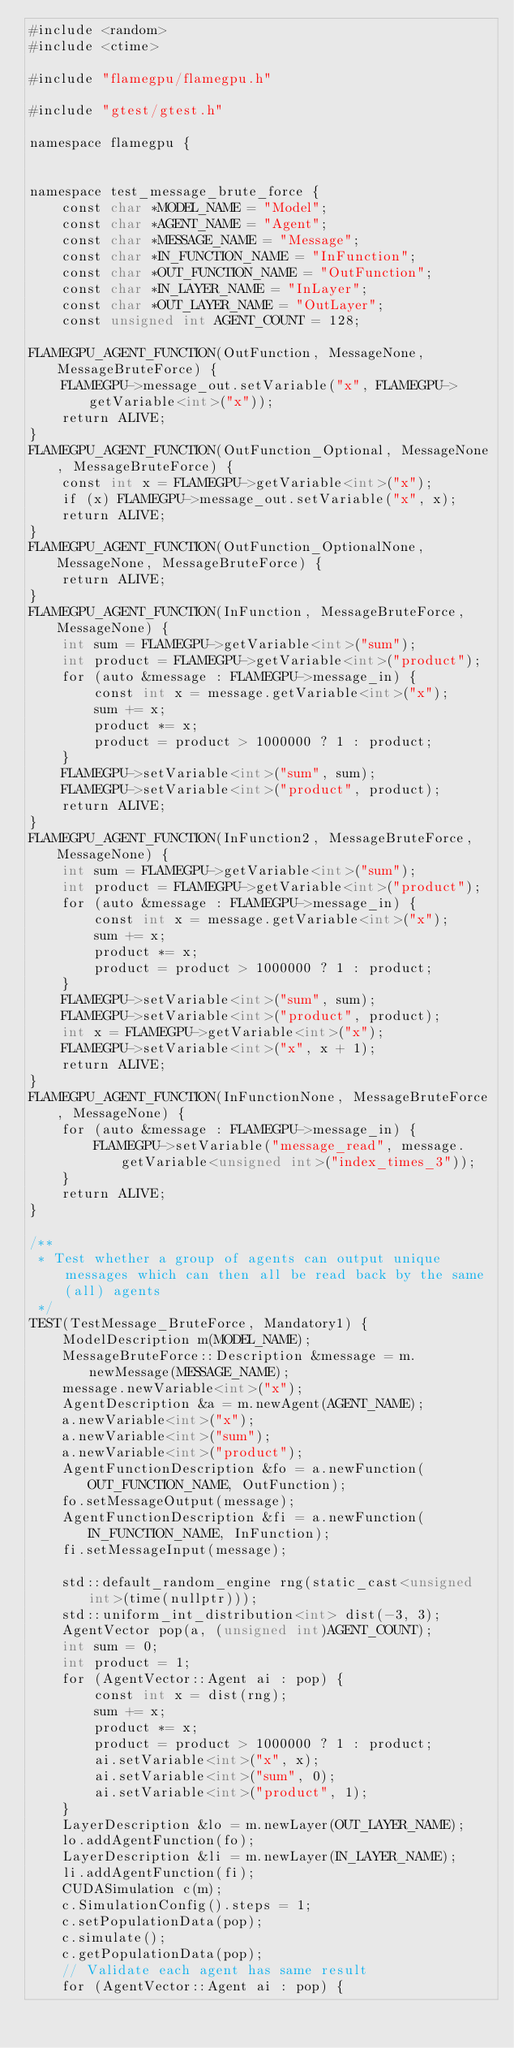<code> <loc_0><loc_0><loc_500><loc_500><_Cuda_>#include <random>
#include <ctime>

#include "flamegpu/flamegpu.h"

#include "gtest/gtest.h"

namespace flamegpu {


namespace test_message_brute_force {
    const char *MODEL_NAME = "Model";
    const char *AGENT_NAME = "Agent";
    const char *MESSAGE_NAME = "Message";
    const char *IN_FUNCTION_NAME = "InFunction";
    const char *OUT_FUNCTION_NAME = "OutFunction";
    const char *IN_LAYER_NAME = "InLayer";
    const char *OUT_LAYER_NAME = "OutLayer";
    const unsigned int AGENT_COUNT = 128;

FLAMEGPU_AGENT_FUNCTION(OutFunction, MessageNone, MessageBruteForce) {
    FLAMEGPU->message_out.setVariable("x", FLAMEGPU->getVariable<int>("x"));
    return ALIVE;
}
FLAMEGPU_AGENT_FUNCTION(OutFunction_Optional, MessageNone, MessageBruteForce) {
    const int x = FLAMEGPU->getVariable<int>("x");
    if (x) FLAMEGPU->message_out.setVariable("x", x);
    return ALIVE;
}
FLAMEGPU_AGENT_FUNCTION(OutFunction_OptionalNone, MessageNone, MessageBruteForce) {
    return ALIVE;
}
FLAMEGPU_AGENT_FUNCTION(InFunction, MessageBruteForce, MessageNone) {
    int sum = FLAMEGPU->getVariable<int>("sum");
    int product = FLAMEGPU->getVariable<int>("product");
    for (auto &message : FLAMEGPU->message_in) {
        const int x = message.getVariable<int>("x");
        sum += x;
        product *= x;
        product = product > 1000000 ? 1 : product;
    }
    FLAMEGPU->setVariable<int>("sum", sum);
    FLAMEGPU->setVariable<int>("product", product);
    return ALIVE;
}
FLAMEGPU_AGENT_FUNCTION(InFunction2, MessageBruteForce, MessageNone) {
    int sum = FLAMEGPU->getVariable<int>("sum");
    int product = FLAMEGPU->getVariable<int>("product");
    for (auto &message : FLAMEGPU->message_in) {
        const int x = message.getVariable<int>("x");
        sum += x;
        product *= x;
        product = product > 1000000 ? 1 : product;
    }
    FLAMEGPU->setVariable<int>("sum", sum);
    FLAMEGPU->setVariable<int>("product", product);
    int x = FLAMEGPU->getVariable<int>("x");
    FLAMEGPU->setVariable<int>("x", x + 1);
    return ALIVE;
}
FLAMEGPU_AGENT_FUNCTION(InFunctionNone, MessageBruteForce, MessageNone) {
    for (auto &message : FLAMEGPU->message_in) {
        FLAMEGPU->setVariable("message_read", message.getVariable<unsigned int>("index_times_3"));
    }
    return ALIVE;
}

/**
 * Test whether a group of agents can output unique messages which can then all be read back by the same (all) agents
 */
TEST(TestMessage_BruteForce, Mandatory1) {
    ModelDescription m(MODEL_NAME);
    MessageBruteForce::Description &message = m.newMessage(MESSAGE_NAME);
    message.newVariable<int>("x");
    AgentDescription &a = m.newAgent(AGENT_NAME);
    a.newVariable<int>("x");
    a.newVariable<int>("sum");
    a.newVariable<int>("product");
    AgentFunctionDescription &fo = a.newFunction(OUT_FUNCTION_NAME, OutFunction);
    fo.setMessageOutput(message);
    AgentFunctionDescription &fi = a.newFunction(IN_FUNCTION_NAME, InFunction);
    fi.setMessageInput(message);

    std::default_random_engine rng(static_cast<unsigned int>(time(nullptr)));
    std::uniform_int_distribution<int> dist(-3, 3);
    AgentVector pop(a, (unsigned int)AGENT_COUNT);
    int sum = 0;
    int product = 1;
    for (AgentVector::Agent ai : pop) {
        const int x = dist(rng);
        sum += x;
        product *= x;
        product = product > 1000000 ? 1 : product;
        ai.setVariable<int>("x", x);
        ai.setVariable<int>("sum", 0);
        ai.setVariable<int>("product", 1);
    }
    LayerDescription &lo = m.newLayer(OUT_LAYER_NAME);
    lo.addAgentFunction(fo);
    LayerDescription &li = m.newLayer(IN_LAYER_NAME);
    li.addAgentFunction(fi);
    CUDASimulation c(m);
    c.SimulationConfig().steps = 1;
    c.setPopulationData(pop);
    c.simulate();
    c.getPopulationData(pop);
    // Validate each agent has same result
    for (AgentVector::Agent ai : pop) {</code> 